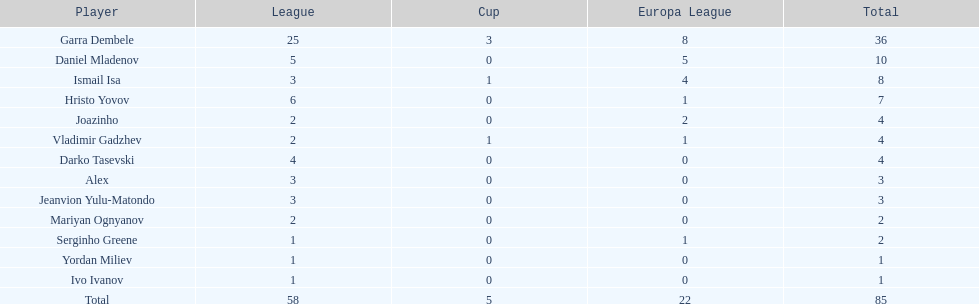What is the difference between vladimir gadzhev and yordan miliev's scores? 3. 